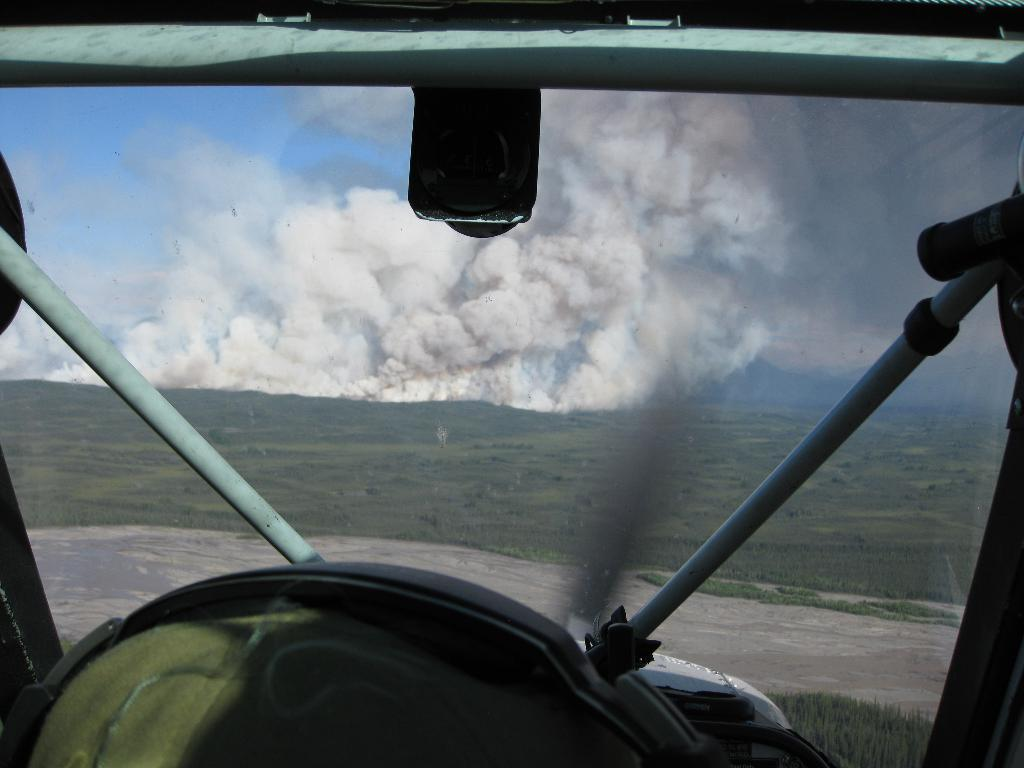What is the perspective of the image? The image is taken from a parachute. What can be seen in the middle of the image? There is smoke in the middle of the image. What type of landscape is visible at the bottom of the image? There is green land at the bottom of the image. What type of marble is used to decorate the stem of the stick in the image? There is no marble, stem, or stick present in the image. 